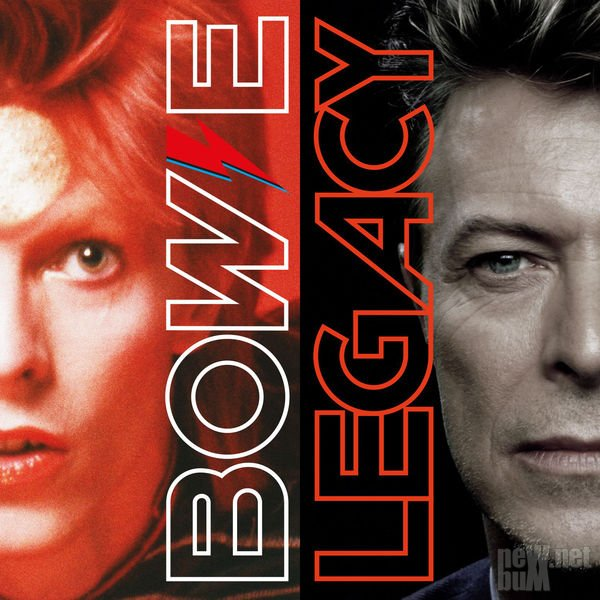What era does the left portrait likely belong to? The left portrait, with its bold lightning bolt design and vibrant red hair, likely belongs to an era characterized by glam rock – specifically the 1970s. This aesthetic aligns with the visual style popularized by musicians who embraced elaborate and theatrical personas during this time. The prominence of the lightning bolt suggests a connection to a period in music history where experimentation with visual identity was key. Why would an artist choose to adopt such a dramatic look? An artist might choose to adopt a dramatic look to stand out, create a memorable image, and cultivate a unique brand. This helps in distinguishing themselves in a crowded industry and can be a part of storytelling in their performances and music. The dramatic look can also signify a particular phase or alter ego in the artist's career, allowing them to explore different aspects of their creativity and connect with their audience on a deeper level. 